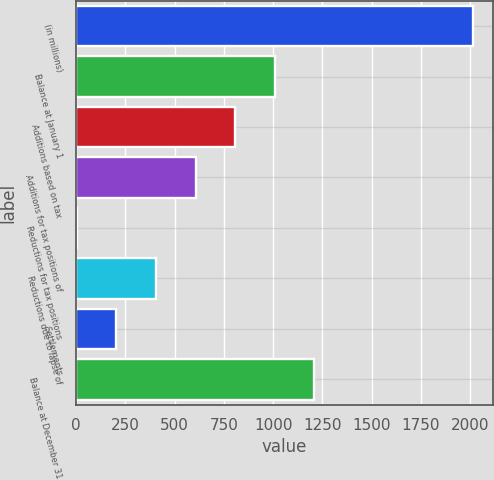Convert chart. <chart><loc_0><loc_0><loc_500><loc_500><bar_chart><fcel>(in millions)<fcel>Balance at January 1<fcel>Additions based on tax<fcel>Additions for tax positions of<fcel>Reductions for tax positions<fcel>Reductions due to lapse of<fcel>Settlements<fcel>Balance at December 31<nl><fcel>2014<fcel>1008.5<fcel>807.4<fcel>606.3<fcel>3<fcel>405.2<fcel>204.1<fcel>1209.6<nl></chart> 